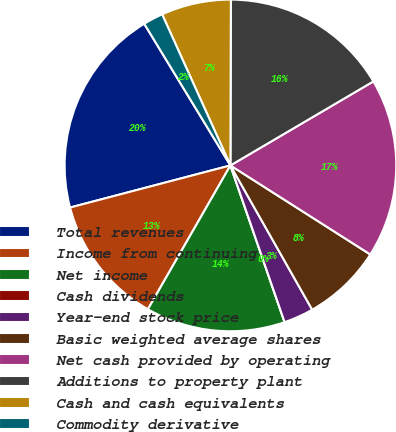<chart> <loc_0><loc_0><loc_500><loc_500><pie_chart><fcel>Total revenues<fcel>Income from continuing<fcel>Net income<fcel>Cash dividends<fcel>Year-end stock price<fcel>Basic weighted average shares<fcel>Net cash provided by operating<fcel>Additions to property plant<fcel>Cash and cash equivalents<fcel>Commodity derivative<nl><fcel>20.39%<fcel>12.62%<fcel>13.59%<fcel>0.0%<fcel>2.91%<fcel>7.77%<fcel>17.48%<fcel>16.5%<fcel>6.8%<fcel>1.94%<nl></chart> 